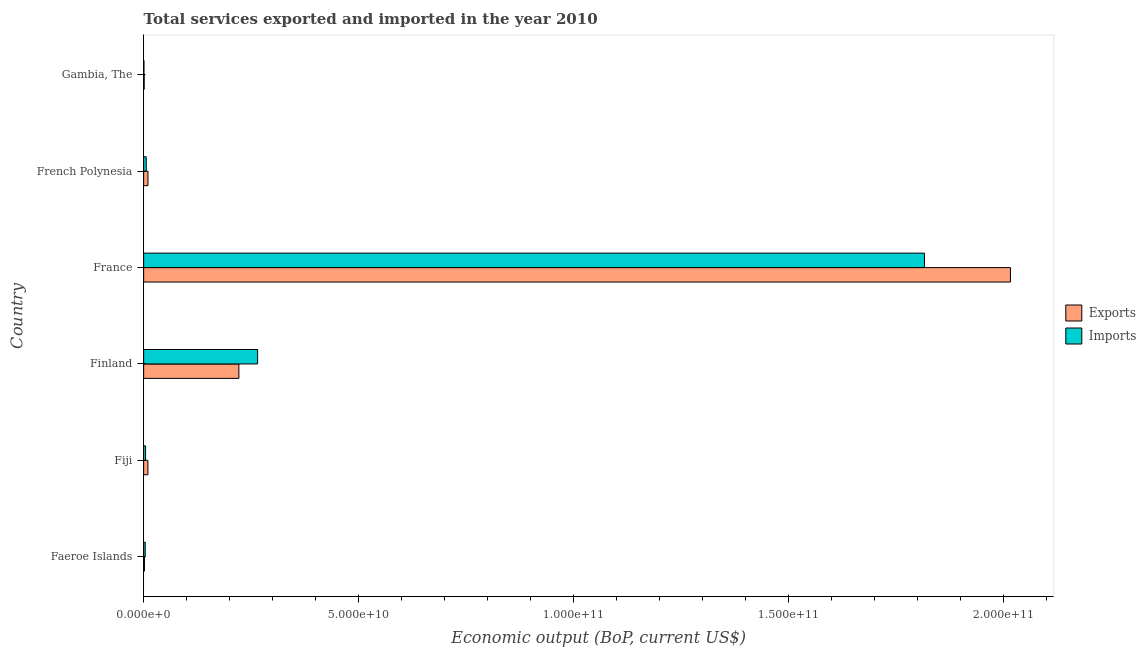Are the number of bars on each tick of the Y-axis equal?
Provide a succinct answer. Yes. How many bars are there on the 3rd tick from the top?
Your response must be concise. 2. How many bars are there on the 4th tick from the bottom?
Give a very brief answer. 2. What is the label of the 4th group of bars from the top?
Offer a terse response. Finland. What is the amount of service exports in French Polynesia?
Ensure brevity in your answer.  1.01e+09. Across all countries, what is the maximum amount of service exports?
Your answer should be compact. 2.02e+11. Across all countries, what is the minimum amount of service exports?
Offer a terse response. 1.31e+08. In which country was the amount of service exports minimum?
Provide a succinct answer. Gambia, The. What is the total amount of service exports in the graph?
Offer a terse response. 2.26e+11. What is the difference between the amount of service imports in Finland and that in France?
Offer a very short reply. -1.55e+11. What is the difference between the amount of service exports in Finland and the amount of service imports in Faeroe Islands?
Your answer should be compact. 2.18e+1. What is the average amount of service imports per country?
Offer a very short reply. 3.50e+1. What is the difference between the amount of service imports and amount of service exports in Finland?
Give a very brief answer. 4.36e+09. In how many countries, is the amount of service imports greater than 40000000000 US$?
Your response must be concise. 1. What is the ratio of the amount of service imports in Finland to that in France?
Keep it short and to the point. 0.15. What is the difference between the highest and the second highest amount of service exports?
Offer a very short reply. 1.80e+11. What is the difference between the highest and the lowest amount of service exports?
Your answer should be very brief. 2.02e+11. In how many countries, is the amount of service imports greater than the average amount of service imports taken over all countries?
Your answer should be compact. 1. Is the sum of the amount of service exports in Finland and Gambia, The greater than the maximum amount of service imports across all countries?
Provide a short and direct response. No. What does the 1st bar from the top in France represents?
Your response must be concise. Imports. What does the 1st bar from the bottom in Finland represents?
Offer a terse response. Exports. Are all the bars in the graph horizontal?
Your response must be concise. Yes. How many countries are there in the graph?
Provide a short and direct response. 6. What is the difference between two consecutive major ticks on the X-axis?
Provide a succinct answer. 5.00e+1. Are the values on the major ticks of X-axis written in scientific E-notation?
Offer a terse response. Yes. Does the graph contain grids?
Make the answer very short. No. Where does the legend appear in the graph?
Provide a short and direct response. Center right. How many legend labels are there?
Your answer should be compact. 2. What is the title of the graph?
Ensure brevity in your answer.  Total services exported and imported in the year 2010. Does "Sanitation services" appear as one of the legend labels in the graph?
Provide a short and direct response. No. What is the label or title of the X-axis?
Offer a terse response. Economic output (BoP, current US$). What is the Economic output (BoP, current US$) of Exports in Faeroe Islands?
Offer a terse response. 1.91e+08. What is the Economic output (BoP, current US$) in Imports in Faeroe Islands?
Your answer should be compact. 3.66e+08. What is the Economic output (BoP, current US$) in Exports in Fiji?
Offer a terse response. 9.93e+08. What is the Economic output (BoP, current US$) in Imports in Fiji?
Your answer should be compact. 4.50e+08. What is the Economic output (BoP, current US$) of Exports in Finland?
Provide a succinct answer. 2.22e+1. What is the Economic output (BoP, current US$) in Imports in Finland?
Provide a succinct answer. 2.65e+1. What is the Economic output (BoP, current US$) in Exports in France?
Make the answer very short. 2.02e+11. What is the Economic output (BoP, current US$) of Imports in France?
Keep it short and to the point. 1.82e+11. What is the Economic output (BoP, current US$) of Exports in French Polynesia?
Your answer should be very brief. 1.01e+09. What is the Economic output (BoP, current US$) in Imports in French Polynesia?
Your answer should be very brief. 5.98e+08. What is the Economic output (BoP, current US$) in Exports in Gambia, The?
Make the answer very short. 1.31e+08. What is the Economic output (BoP, current US$) of Imports in Gambia, The?
Offer a terse response. 7.32e+07. Across all countries, what is the maximum Economic output (BoP, current US$) in Exports?
Your answer should be compact. 2.02e+11. Across all countries, what is the maximum Economic output (BoP, current US$) of Imports?
Provide a succinct answer. 1.82e+11. Across all countries, what is the minimum Economic output (BoP, current US$) in Exports?
Offer a very short reply. 1.31e+08. Across all countries, what is the minimum Economic output (BoP, current US$) in Imports?
Provide a short and direct response. 7.32e+07. What is the total Economic output (BoP, current US$) in Exports in the graph?
Your answer should be compact. 2.26e+11. What is the total Economic output (BoP, current US$) of Imports in the graph?
Your answer should be very brief. 2.10e+11. What is the difference between the Economic output (BoP, current US$) of Exports in Faeroe Islands and that in Fiji?
Make the answer very short. -8.03e+08. What is the difference between the Economic output (BoP, current US$) of Imports in Faeroe Islands and that in Fiji?
Your answer should be very brief. -8.37e+07. What is the difference between the Economic output (BoP, current US$) in Exports in Faeroe Islands and that in Finland?
Give a very brief answer. -2.20e+1. What is the difference between the Economic output (BoP, current US$) of Imports in Faeroe Islands and that in Finland?
Ensure brevity in your answer.  -2.62e+1. What is the difference between the Economic output (BoP, current US$) of Exports in Faeroe Islands and that in France?
Make the answer very short. -2.02e+11. What is the difference between the Economic output (BoP, current US$) in Imports in Faeroe Islands and that in France?
Your response must be concise. -1.81e+11. What is the difference between the Economic output (BoP, current US$) of Exports in Faeroe Islands and that in French Polynesia?
Your answer should be compact. -8.15e+08. What is the difference between the Economic output (BoP, current US$) in Imports in Faeroe Islands and that in French Polynesia?
Your response must be concise. -2.32e+08. What is the difference between the Economic output (BoP, current US$) of Exports in Faeroe Islands and that in Gambia, The?
Your response must be concise. 6.00e+07. What is the difference between the Economic output (BoP, current US$) of Imports in Faeroe Islands and that in Gambia, The?
Your response must be concise. 2.93e+08. What is the difference between the Economic output (BoP, current US$) in Exports in Fiji and that in Finland?
Offer a very short reply. -2.12e+1. What is the difference between the Economic output (BoP, current US$) in Imports in Fiji and that in Finland?
Give a very brief answer. -2.61e+1. What is the difference between the Economic output (BoP, current US$) of Exports in Fiji and that in France?
Ensure brevity in your answer.  -2.01e+11. What is the difference between the Economic output (BoP, current US$) in Imports in Fiji and that in France?
Offer a very short reply. -1.81e+11. What is the difference between the Economic output (BoP, current US$) in Exports in Fiji and that in French Polynesia?
Your answer should be compact. -1.23e+07. What is the difference between the Economic output (BoP, current US$) in Imports in Fiji and that in French Polynesia?
Make the answer very short. -1.48e+08. What is the difference between the Economic output (BoP, current US$) in Exports in Fiji and that in Gambia, The?
Make the answer very short. 8.63e+08. What is the difference between the Economic output (BoP, current US$) of Imports in Fiji and that in Gambia, The?
Ensure brevity in your answer.  3.77e+08. What is the difference between the Economic output (BoP, current US$) of Exports in Finland and that in France?
Offer a very short reply. -1.80e+11. What is the difference between the Economic output (BoP, current US$) of Imports in Finland and that in France?
Provide a short and direct response. -1.55e+11. What is the difference between the Economic output (BoP, current US$) in Exports in Finland and that in French Polynesia?
Your response must be concise. 2.12e+1. What is the difference between the Economic output (BoP, current US$) in Imports in Finland and that in French Polynesia?
Offer a very short reply. 2.59e+1. What is the difference between the Economic output (BoP, current US$) of Exports in Finland and that in Gambia, The?
Give a very brief answer. 2.20e+1. What is the difference between the Economic output (BoP, current US$) in Imports in Finland and that in Gambia, The?
Offer a terse response. 2.64e+1. What is the difference between the Economic output (BoP, current US$) in Exports in France and that in French Polynesia?
Make the answer very short. 2.01e+11. What is the difference between the Economic output (BoP, current US$) of Imports in France and that in French Polynesia?
Make the answer very short. 1.81e+11. What is the difference between the Economic output (BoP, current US$) in Exports in France and that in Gambia, The?
Give a very brief answer. 2.02e+11. What is the difference between the Economic output (BoP, current US$) of Imports in France and that in Gambia, The?
Give a very brief answer. 1.82e+11. What is the difference between the Economic output (BoP, current US$) in Exports in French Polynesia and that in Gambia, The?
Offer a very short reply. 8.75e+08. What is the difference between the Economic output (BoP, current US$) in Imports in French Polynesia and that in Gambia, The?
Your answer should be compact. 5.25e+08. What is the difference between the Economic output (BoP, current US$) of Exports in Faeroe Islands and the Economic output (BoP, current US$) of Imports in Fiji?
Your answer should be very brief. -2.59e+08. What is the difference between the Economic output (BoP, current US$) in Exports in Faeroe Islands and the Economic output (BoP, current US$) in Imports in Finland?
Provide a short and direct response. -2.63e+1. What is the difference between the Economic output (BoP, current US$) of Exports in Faeroe Islands and the Economic output (BoP, current US$) of Imports in France?
Offer a terse response. -1.82e+11. What is the difference between the Economic output (BoP, current US$) of Exports in Faeroe Islands and the Economic output (BoP, current US$) of Imports in French Polynesia?
Keep it short and to the point. -4.07e+08. What is the difference between the Economic output (BoP, current US$) in Exports in Faeroe Islands and the Economic output (BoP, current US$) in Imports in Gambia, The?
Ensure brevity in your answer.  1.18e+08. What is the difference between the Economic output (BoP, current US$) of Exports in Fiji and the Economic output (BoP, current US$) of Imports in Finland?
Ensure brevity in your answer.  -2.55e+1. What is the difference between the Economic output (BoP, current US$) of Exports in Fiji and the Economic output (BoP, current US$) of Imports in France?
Ensure brevity in your answer.  -1.81e+11. What is the difference between the Economic output (BoP, current US$) in Exports in Fiji and the Economic output (BoP, current US$) in Imports in French Polynesia?
Keep it short and to the point. 3.96e+08. What is the difference between the Economic output (BoP, current US$) of Exports in Fiji and the Economic output (BoP, current US$) of Imports in Gambia, The?
Provide a short and direct response. 9.20e+08. What is the difference between the Economic output (BoP, current US$) of Exports in Finland and the Economic output (BoP, current US$) of Imports in France?
Give a very brief answer. -1.60e+11. What is the difference between the Economic output (BoP, current US$) of Exports in Finland and the Economic output (BoP, current US$) of Imports in French Polynesia?
Your answer should be compact. 2.16e+1. What is the difference between the Economic output (BoP, current US$) of Exports in Finland and the Economic output (BoP, current US$) of Imports in Gambia, The?
Keep it short and to the point. 2.21e+1. What is the difference between the Economic output (BoP, current US$) of Exports in France and the Economic output (BoP, current US$) of Imports in French Polynesia?
Provide a succinct answer. 2.01e+11. What is the difference between the Economic output (BoP, current US$) in Exports in France and the Economic output (BoP, current US$) in Imports in Gambia, The?
Provide a short and direct response. 2.02e+11. What is the difference between the Economic output (BoP, current US$) of Exports in French Polynesia and the Economic output (BoP, current US$) of Imports in Gambia, The?
Offer a terse response. 9.33e+08. What is the average Economic output (BoP, current US$) in Exports per country?
Your answer should be very brief. 3.77e+1. What is the average Economic output (BoP, current US$) in Imports per country?
Offer a terse response. 3.50e+1. What is the difference between the Economic output (BoP, current US$) in Exports and Economic output (BoP, current US$) in Imports in Faeroe Islands?
Offer a very short reply. -1.75e+08. What is the difference between the Economic output (BoP, current US$) of Exports and Economic output (BoP, current US$) of Imports in Fiji?
Ensure brevity in your answer.  5.44e+08. What is the difference between the Economic output (BoP, current US$) in Exports and Economic output (BoP, current US$) in Imports in Finland?
Ensure brevity in your answer.  -4.36e+09. What is the difference between the Economic output (BoP, current US$) in Exports and Economic output (BoP, current US$) in Imports in France?
Your response must be concise. 2.00e+1. What is the difference between the Economic output (BoP, current US$) in Exports and Economic output (BoP, current US$) in Imports in French Polynesia?
Provide a short and direct response. 4.08e+08. What is the difference between the Economic output (BoP, current US$) in Exports and Economic output (BoP, current US$) in Imports in Gambia, The?
Provide a succinct answer. 5.75e+07. What is the ratio of the Economic output (BoP, current US$) of Exports in Faeroe Islands to that in Fiji?
Your response must be concise. 0.19. What is the ratio of the Economic output (BoP, current US$) in Imports in Faeroe Islands to that in Fiji?
Give a very brief answer. 0.81. What is the ratio of the Economic output (BoP, current US$) in Exports in Faeroe Islands to that in Finland?
Ensure brevity in your answer.  0.01. What is the ratio of the Economic output (BoP, current US$) of Imports in Faeroe Islands to that in Finland?
Offer a terse response. 0.01. What is the ratio of the Economic output (BoP, current US$) in Exports in Faeroe Islands to that in France?
Your answer should be very brief. 0. What is the ratio of the Economic output (BoP, current US$) in Imports in Faeroe Islands to that in France?
Provide a succinct answer. 0. What is the ratio of the Economic output (BoP, current US$) of Exports in Faeroe Islands to that in French Polynesia?
Keep it short and to the point. 0.19. What is the ratio of the Economic output (BoP, current US$) in Imports in Faeroe Islands to that in French Polynesia?
Make the answer very short. 0.61. What is the ratio of the Economic output (BoP, current US$) of Exports in Faeroe Islands to that in Gambia, The?
Make the answer very short. 1.46. What is the ratio of the Economic output (BoP, current US$) of Imports in Faeroe Islands to that in Gambia, The?
Provide a short and direct response. 5. What is the ratio of the Economic output (BoP, current US$) in Exports in Fiji to that in Finland?
Your answer should be very brief. 0.04. What is the ratio of the Economic output (BoP, current US$) of Imports in Fiji to that in Finland?
Your response must be concise. 0.02. What is the ratio of the Economic output (BoP, current US$) of Exports in Fiji to that in France?
Offer a terse response. 0. What is the ratio of the Economic output (BoP, current US$) of Imports in Fiji to that in France?
Your response must be concise. 0. What is the ratio of the Economic output (BoP, current US$) of Exports in Fiji to that in French Polynesia?
Make the answer very short. 0.99. What is the ratio of the Economic output (BoP, current US$) in Imports in Fiji to that in French Polynesia?
Keep it short and to the point. 0.75. What is the ratio of the Economic output (BoP, current US$) in Exports in Fiji to that in Gambia, The?
Offer a terse response. 7.6. What is the ratio of the Economic output (BoP, current US$) of Imports in Fiji to that in Gambia, The?
Ensure brevity in your answer.  6.15. What is the ratio of the Economic output (BoP, current US$) of Exports in Finland to that in France?
Your response must be concise. 0.11. What is the ratio of the Economic output (BoP, current US$) of Imports in Finland to that in France?
Offer a very short reply. 0.15. What is the ratio of the Economic output (BoP, current US$) of Exports in Finland to that in French Polynesia?
Make the answer very short. 22.03. What is the ratio of the Economic output (BoP, current US$) of Imports in Finland to that in French Polynesia?
Offer a terse response. 44.36. What is the ratio of the Economic output (BoP, current US$) of Exports in Finland to that in Gambia, The?
Provide a succinct answer. 169.61. What is the ratio of the Economic output (BoP, current US$) in Imports in Finland to that in Gambia, The?
Your response must be concise. 362.46. What is the ratio of the Economic output (BoP, current US$) in Exports in France to that in French Polynesia?
Offer a terse response. 200.54. What is the ratio of the Economic output (BoP, current US$) of Imports in France to that in French Polynesia?
Ensure brevity in your answer.  303.88. What is the ratio of the Economic output (BoP, current US$) of Exports in France to that in Gambia, The?
Provide a succinct answer. 1543.9. What is the ratio of the Economic output (BoP, current US$) in Imports in France to that in Gambia, The?
Provide a short and direct response. 2483.01. What is the ratio of the Economic output (BoP, current US$) of Exports in French Polynesia to that in Gambia, The?
Make the answer very short. 7.7. What is the ratio of the Economic output (BoP, current US$) of Imports in French Polynesia to that in Gambia, The?
Provide a succinct answer. 8.17. What is the difference between the highest and the second highest Economic output (BoP, current US$) of Exports?
Keep it short and to the point. 1.80e+11. What is the difference between the highest and the second highest Economic output (BoP, current US$) of Imports?
Your answer should be very brief. 1.55e+11. What is the difference between the highest and the lowest Economic output (BoP, current US$) of Exports?
Give a very brief answer. 2.02e+11. What is the difference between the highest and the lowest Economic output (BoP, current US$) of Imports?
Offer a terse response. 1.82e+11. 